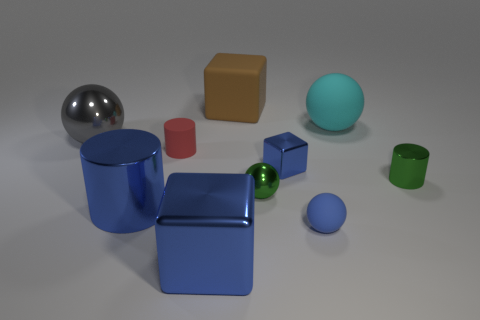Subtract all red cylinders. Subtract all purple blocks. How many cylinders are left? 2 Subtract all cubes. How many objects are left? 7 Add 5 brown rubber blocks. How many brown rubber blocks exist? 6 Subtract 0 yellow balls. How many objects are left? 10 Subtract all big cyan rubber balls. Subtract all tiny green blocks. How many objects are left? 9 Add 2 large gray metallic objects. How many large gray metallic objects are left? 3 